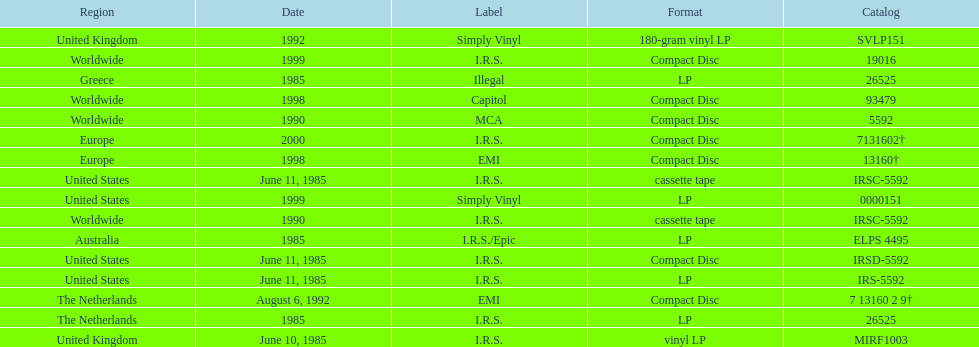Name another region for the 1985 release other than greece. Australia. 